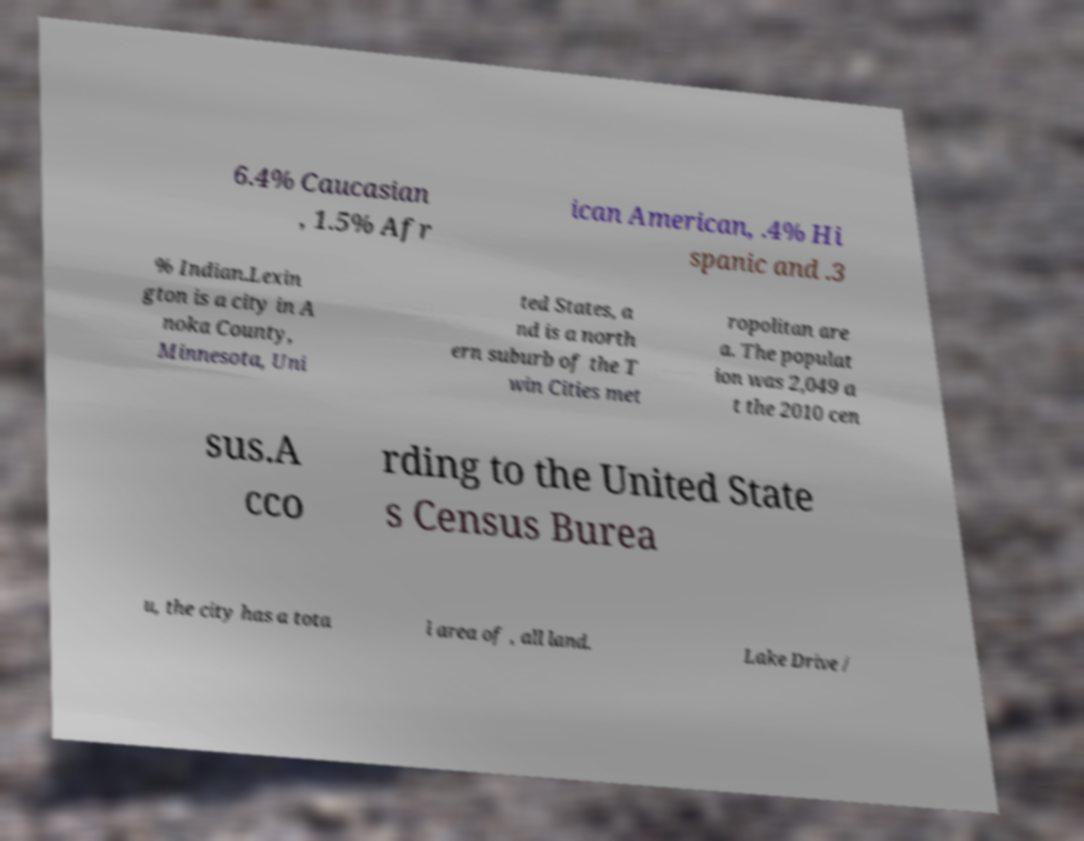Please identify and transcribe the text found in this image. 6.4% Caucasian , 1.5% Afr ican American, .4% Hi spanic and .3 % Indian.Lexin gton is a city in A noka County, Minnesota, Uni ted States, a nd is a north ern suburb of the T win Cities met ropolitan are a. The populat ion was 2,049 a t the 2010 cen sus.A cco rding to the United State s Census Burea u, the city has a tota l area of , all land. Lake Drive / 